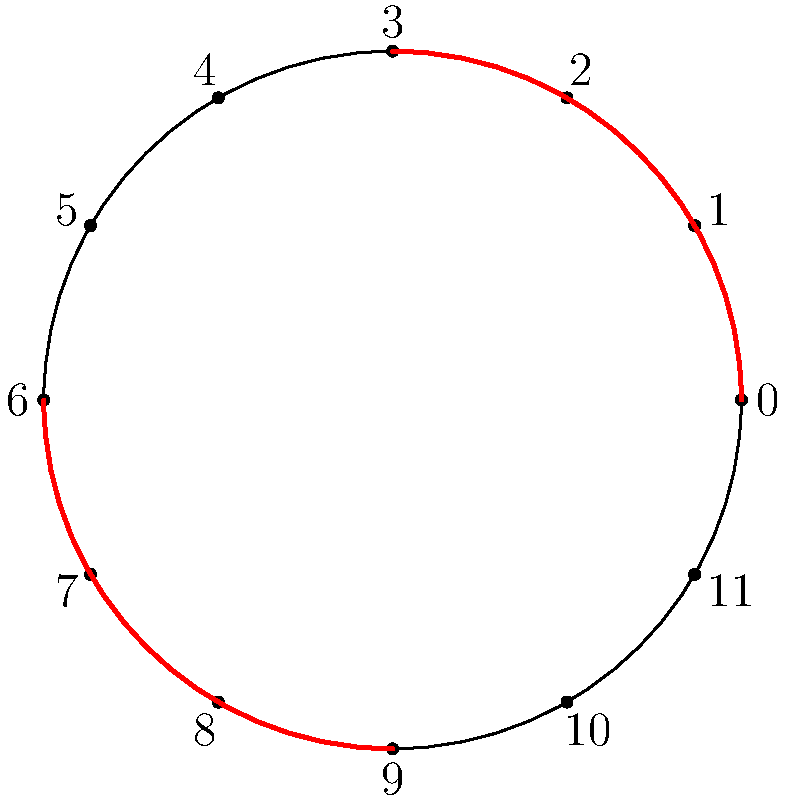In the circle of fifths diagram above, which two quadrants are highlighted, and what common chord progression in Latin pop (excluding Bachata) does this represent? To answer this question, let's follow these steps:

1. Identify the highlighted quadrants:
   - The highlighted areas are the top-right and bottom-left quadrants.
   - In the circle of fifths, these quadrants represent:
     * Top-right: C - G - D - A
     * Bottom-left: F - Bb - Eb - Ab

2. Recognize the chord progression:
   - The highlighted quadrants suggest a I - V - vi - IV progression.
   - This is because:
     * I (tonic) and IV (subdominant) are in the top-right quadrant
     * V (dominant) is also in the top-right quadrant
     * vi (relative minor) is in the bottom-left quadrant

3. Relate to Latin pop:
   - This I - V - vi - IV progression is extremely common in pop music globally, including Latin pop.
   - It's often called the "pop-punk progression" or "sensitive female chord progression."
   - Examples in Latin pop (excluding Bachata) include:
     * "Vivir Mi Vida" by Marc Anthony
     * "Bailando" by Enrique Iglesias
     * "Despacito" by Luis Fonsi and Daddy Yankee (in the chorus)

4. Verify the progression's prevalence:
   - This progression is versatile and emotionally evocative, making it popular across various Latin pop subgenres.
   - It's particularly common in ballads and mid-tempo songs.

Therefore, the highlighted quadrants represent the I - V - vi - IV progression, which is widely used in Latin pop music outside of Bachata.
Answer: I - V - vi - IV progression 